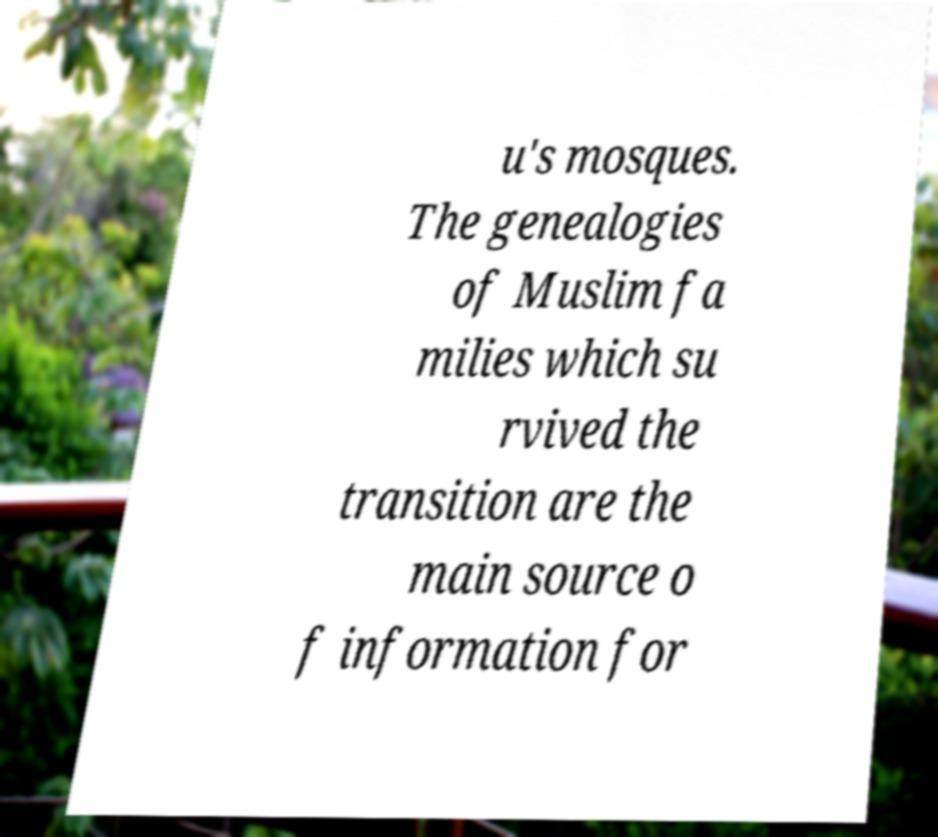Can you read and provide the text displayed in the image?This photo seems to have some interesting text. Can you extract and type it out for me? u's mosques. The genealogies of Muslim fa milies which su rvived the transition are the main source o f information for 